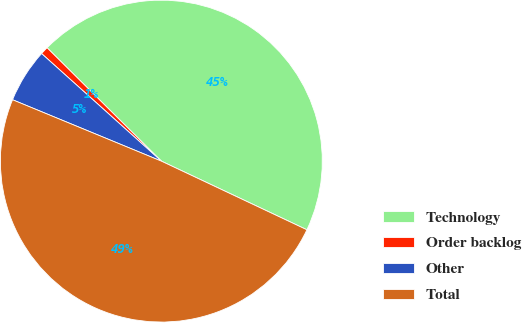<chart> <loc_0><loc_0><loc_500><loc_500><pie_chart><fcel>Technology<fcel>Order backlog<fcel>Other<fcel>Total<nl><fcel>44.58%<fcel>0.79%<fcel>5.42%<fcel>49.21%<nl></chart> 